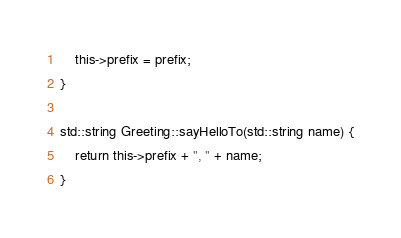<code> <loc_0><loc_0><loc_500><loc_500><_C++_>    this->prefix = prefix;
}

std::string Greeting::sayHelloTo(std::string name) {
    return this->prefix + ", " + name;
}</code> 